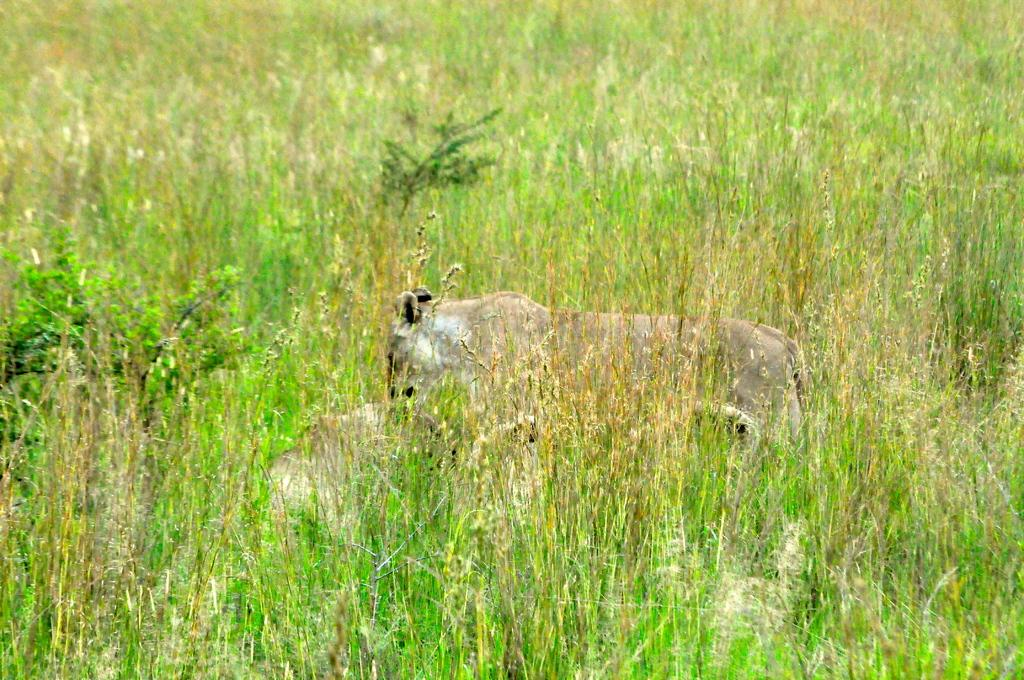What type of living creature is present in the image? There is an animal in the image. What can be seen in the background of the image? There are plants in the background of the image. What type of produce is being served at the animal's birthday party in the image? There is no produce or birthday party present in the image; it only features an animal and plants in the background. 